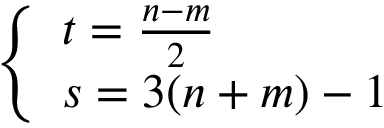Convert formula to latex. <formula><loc_0><loc_0><loc_500><loc_500>\left \{ \begin{array} { l l } { { t = \frac { n - m } { 2 } } } \\ { s = 3 ( n + m ) - 1 } \end{array}</formula> 